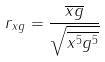Convert formula to latex. <formula><loc_0><loc_0><loc_500><loc_500>r _ { x g } = \frac { \overline { x g } } { \sqrt { \overline { x ^ { 5 } } \overline { g ^ { 5 } } } }</formula> 